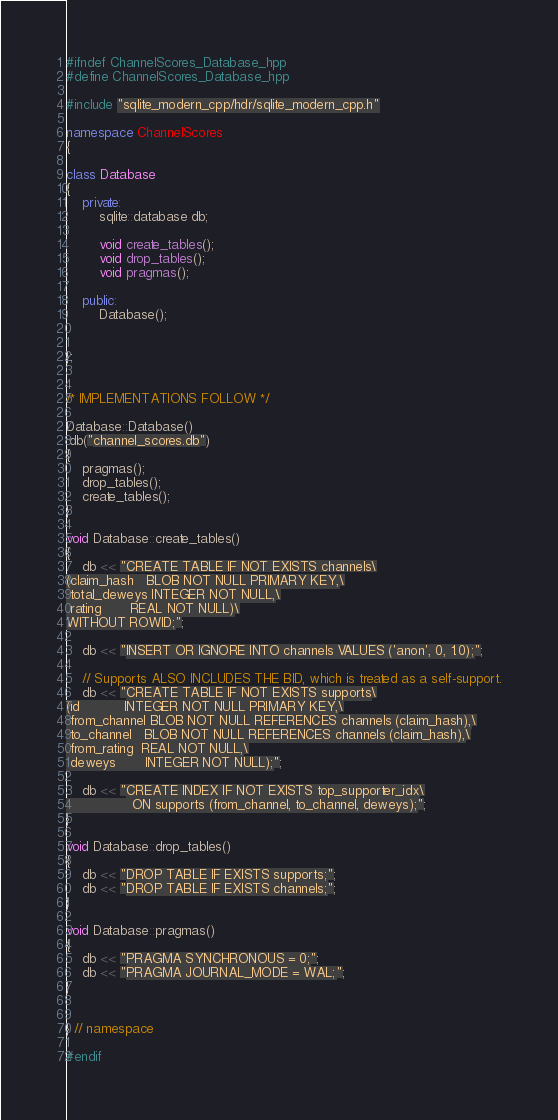<code> <loc_0><loc_0><loc_500><loc_500><_C++_>#ifndef ChannelScores_Database_hpp
#define ChannelScores_Database_hpp

#include "sqlite_modern_cpp/hdr/sqlite_modern_cpp.h"

namespace ChannelScores
{

class Database
{
    private:
        sqlite::database db;

        void create_tables();
        void drop_tables();
        void pragmas();

    public:
        Database();


};


/* IMPLEMENTATIONS FOLLOW */

Database::Database()
:db("channel_scores.db")
{
    pragmas();
    drop_tables();
    create_tables();
}

void Database::create_tables()
{
    db << "CREATE TABLE IF NOT EXISTS channels\
(claim_hash   BLOB NOT NULL PRIMARY KEY,\
 total_deweys INTEGER NOT NULL,\
 rating       REAL NOT NULL)\
WITHOUT ROWID;";

    db << "INSERT OR IGNORE INTO channels VALUES ('anon', 0, 1.0);";

    // Supports ALSO INCLUDES THE BID, which is treated as a self-support.
    db << "CREATE TABLE IF NOT EXISTS supports\
(id           INTEGER NOT NULL PRIMARY KEY,\
 from_channel BLOB NOT NULL REFERENCES channels (claim_hash),\
 to_channel   BLOB NOT NULL REFERENCES channels (claim_hash),\
 from_rating  REAL NOT NULL,\
 deweys       INTEGER NOT NULL);";

    db << "CREATE INDEX IF NOT EXISTS top_supporter_idx\
                ON supports (from_channel, to_channel, deweys);";
}

void Database::drop_tables()
{
    db << "DROP TABLE IF EXISTS supports;";
    db << "DROP TABLE IF EXISTS channels;";
}

void Database::pragmas()
{
    db << "PRAGMA SYNCHRONOUS = 0;";
    db << "PRAGMA JOURNAL_MODE = WAL;";
}


} // namespace

#endif
</code> 